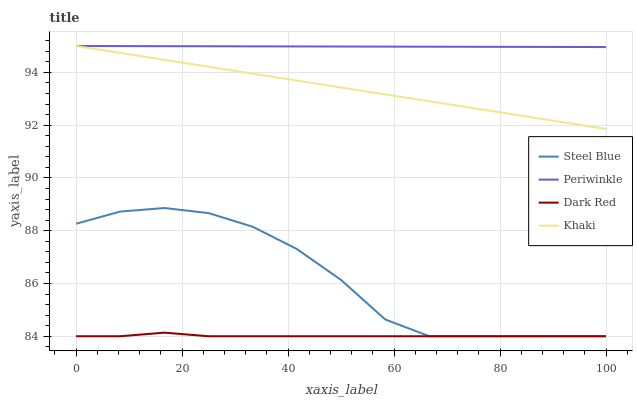Does Dark Red have the minimum area under the curve?
Answer yes or no. Yes. Does Periwinkle have the maximum area under the curve?
Answer yes or no. Yes. Does Khaki have the minimum area under the curve?
Answer yes or no. No. Does Khaki have the maximum area under the curve?
Answer yes or no. No. Is Periwinkle the smoothest?
Answer yes or no. Yes. Is Steel Blue the roughest?
Answer yes or no. Yes. Is Khaki the smoothest?
Answer yes or no. No. Is Khaki the roughest?
Answer yes or no. No. Does Dark Red have the lowest value?
Answer yes or no. Yes. Does Khaki have the lowest value?
Answer yes or no. No. Does Periwinkle have the highest value?
Answer yes or no. Yes. Does Steel Blue have the highest value?
Answer yes or no. No. Is Steel Blue less than Khaki?
Answer yes or no. Yes. Is Khaki greater than Dark Red?
Answer yes or no. Yes. Does Dark Red intersect Steel Blue?
Answer yes or no. Yes. Is Dark Red less than Steel Blue?
Answer yes or no. No. Is Dark Red greater than Steel Blue?
Answer yes or no. No. Does Steel Blue intersect Khaki?
Answer yes or no. No. 